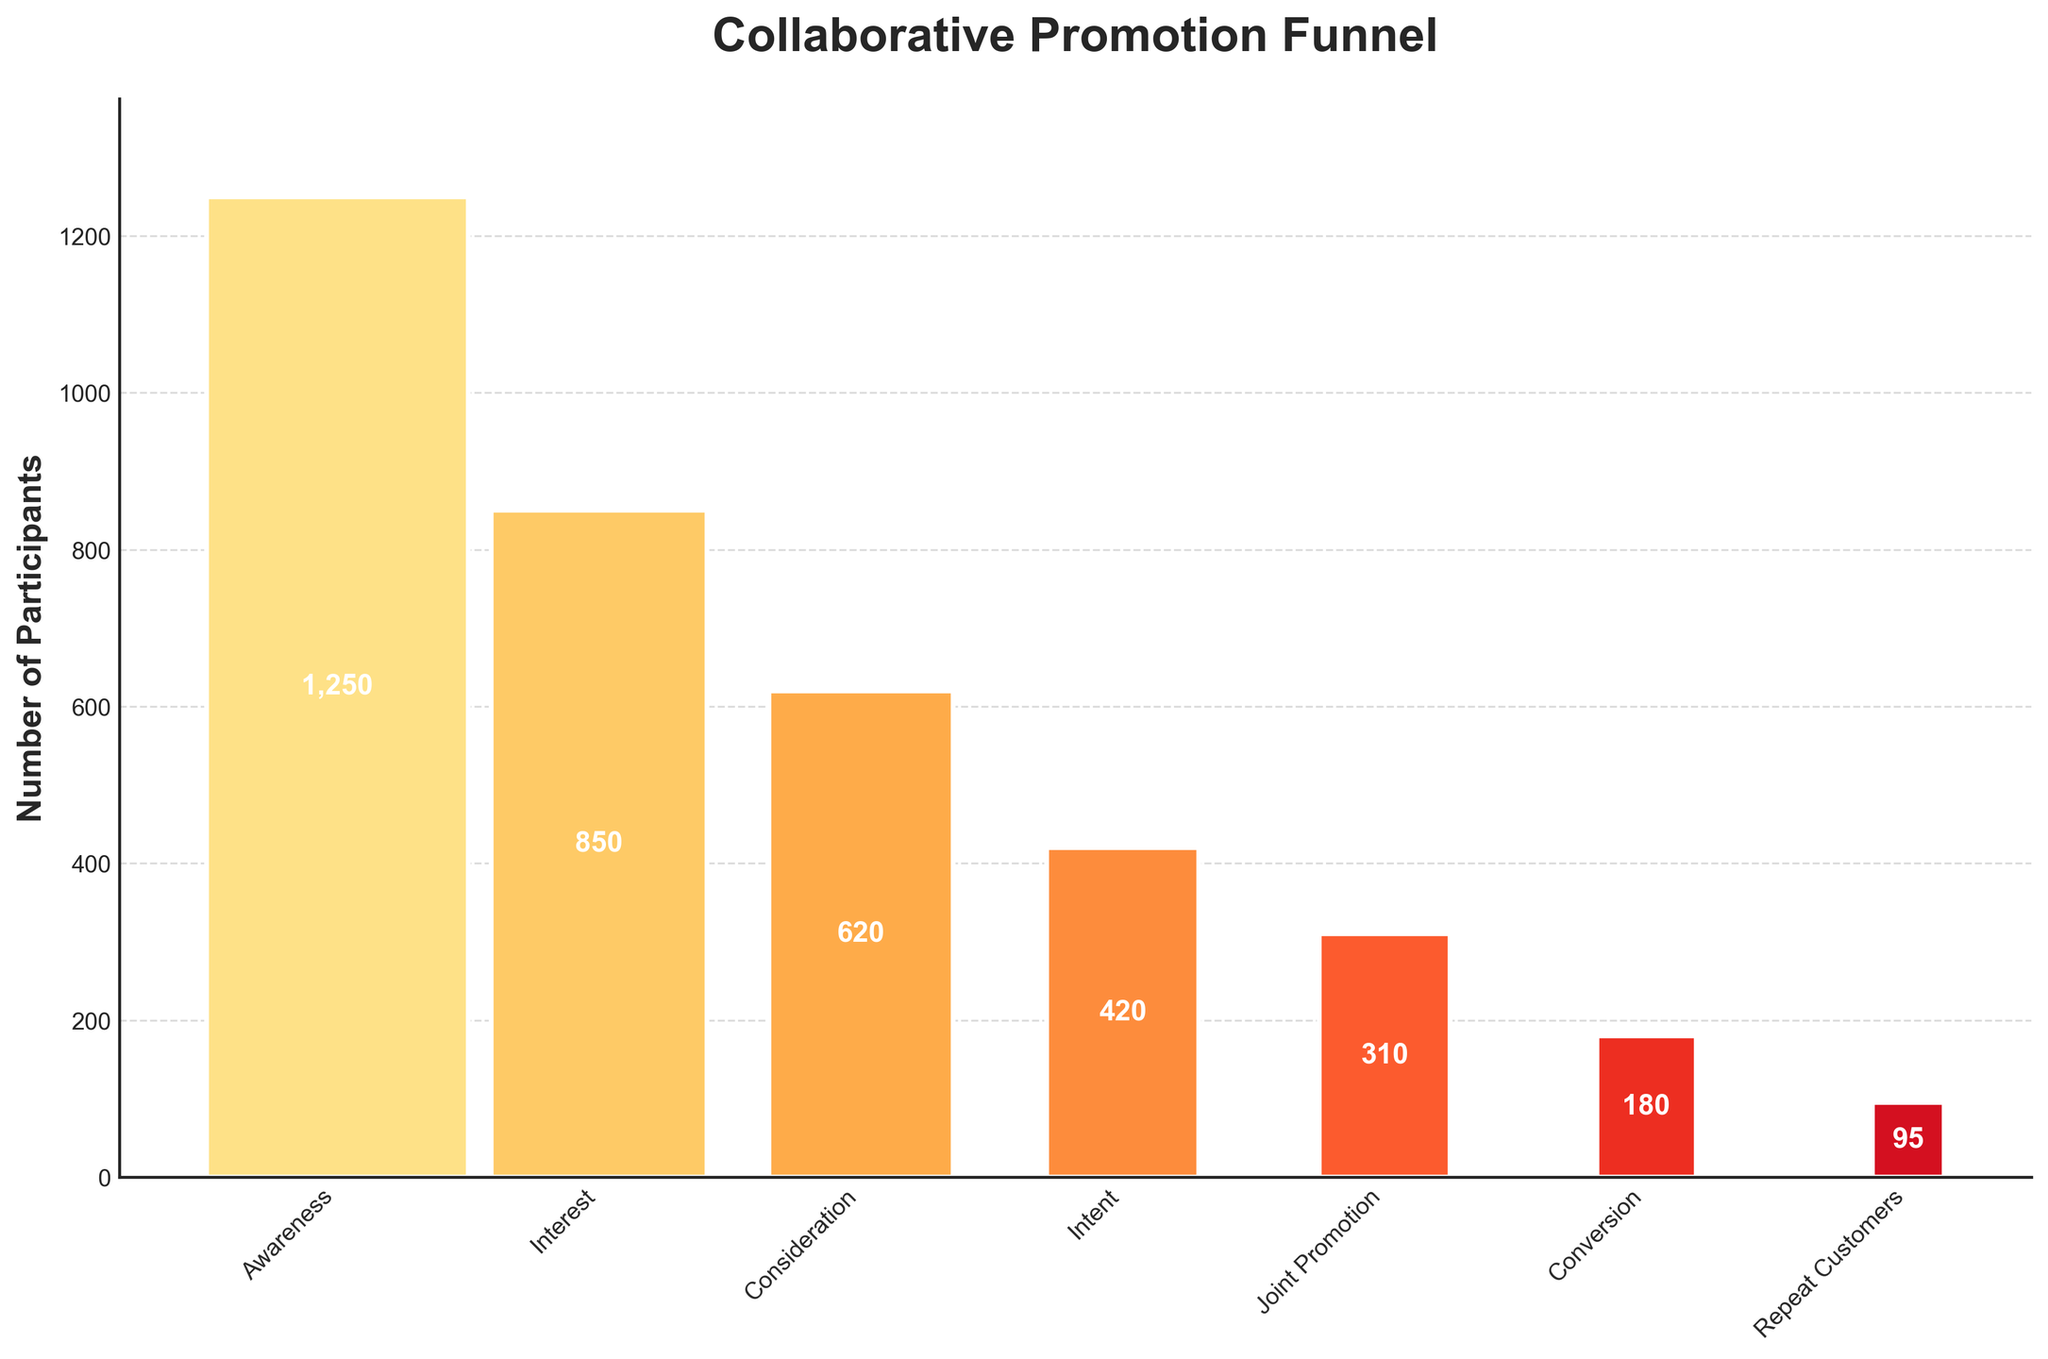What title is given to the funnel chart? The chart's title appears at the top, usually in a larger and bold font, making it easily visible. The title provides a quick understanding of what the chart represents.
Answer: Collaborative Promotion Funnel How many stages does the funnel chart have? The stages in the funnel chart are depicted with distinct bars, each labeled with a stage name. By counting these bars, we can determine the total number of stages.
Answer: 7 What is the number of participants at the 'Interest' stage? In the funnel chart, each stage is labeled, and the corresponding participant count is placed within the bar of that stage. Locate the 'Interest' stage to find its participant count.
Answer: 850 How many participants are there between the 'Intent' and 'Joint Promotion' stages? Identify the participant numbers for both 'Intent' and 'Joint Promotion' stages from the chart. Subtract the number of participants at the 'Joint Promotion' stage from the 'Intent' stage to find the difference.
Answer: 110 Which stage shows the largest drop in participants? Observe the numbers of participants at each stage. Calculate the differences between consecutive stages, and identify which stage transition has the highest decrease in participants.
Answer: Intent to Joint Promotion What's the difference in the number of participants between 'Consideration' and 'Intent'? Locate the participant numbers for the 'Consideration' and 'Intent' stages. Subtract the 'Intent' participants from the 'Consideration' participants to find the difference.
Answer: 200 What percentage of participants move from 'Awareness' to 'Repeat Customers'? Determine the number of participants at the starting ('Awareness') and ending ('Repeat Customers') stages. Divide the number of 'Repeat Customers' by the number of 'Awareness' participants and multiply by 100 to get the percentage.
Answer: 7.6% How many participants are lost from 'Joint Promotion' to 'Repeat Customers'? Find the participant counts for both 'Joint Promotion' and 'Repeat Customers' stages. Subtract the 'Repeat Customers' participants from the 'Joint Promotion' participants to find the loss.
Answer: 215 Which stage has the lowest number of participants? By reviewing all bars and their participant numbers, you can identify the stage with the smallest count.
Answer: Repeat Customers 